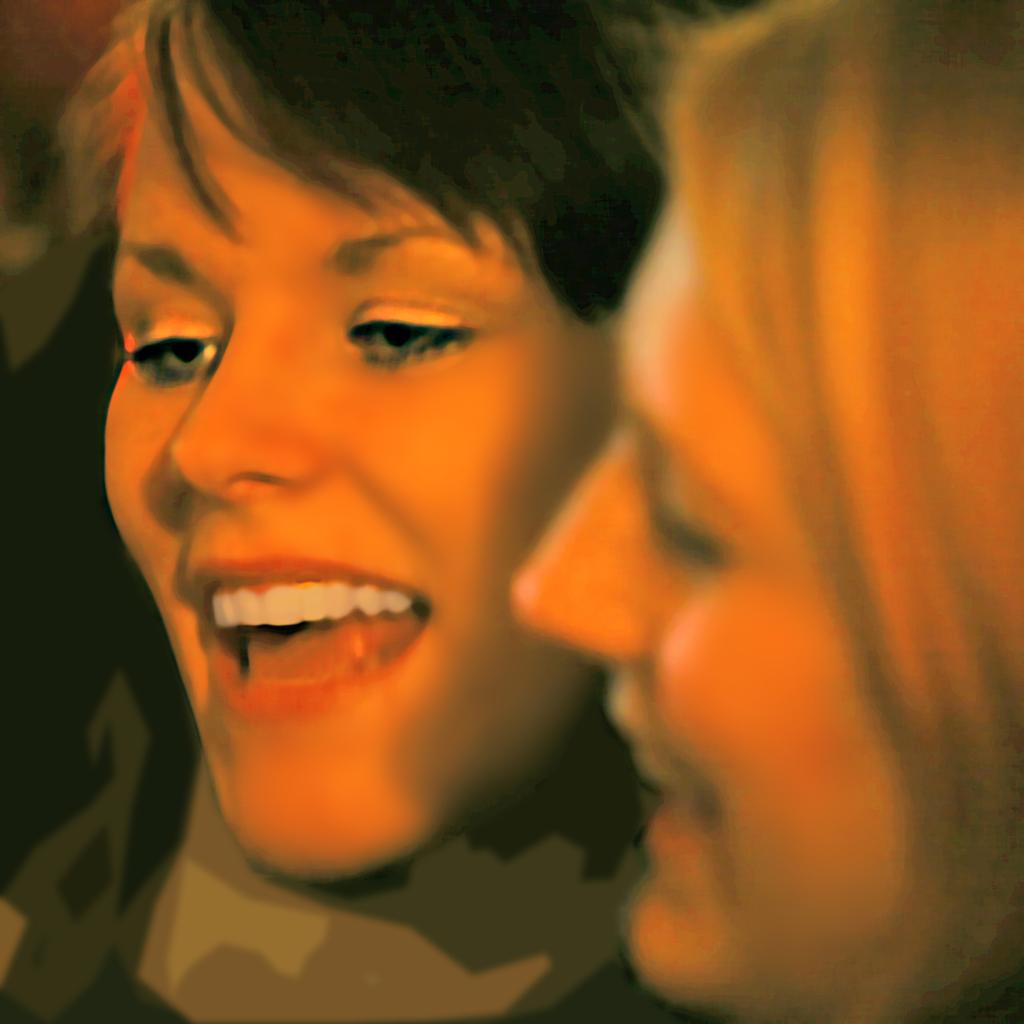How many people are in the image? There are two ladies in the image. What is the facial expression of the ladies? The ladies are smiling. What type of kettle is being used by the ladies in the image? There is no kettle present in the image; it only features two ladies who are smiling. What decision are the ladies making in the image? There is no indication of a decision being made in the image, as it only shows the ladies smiling. 